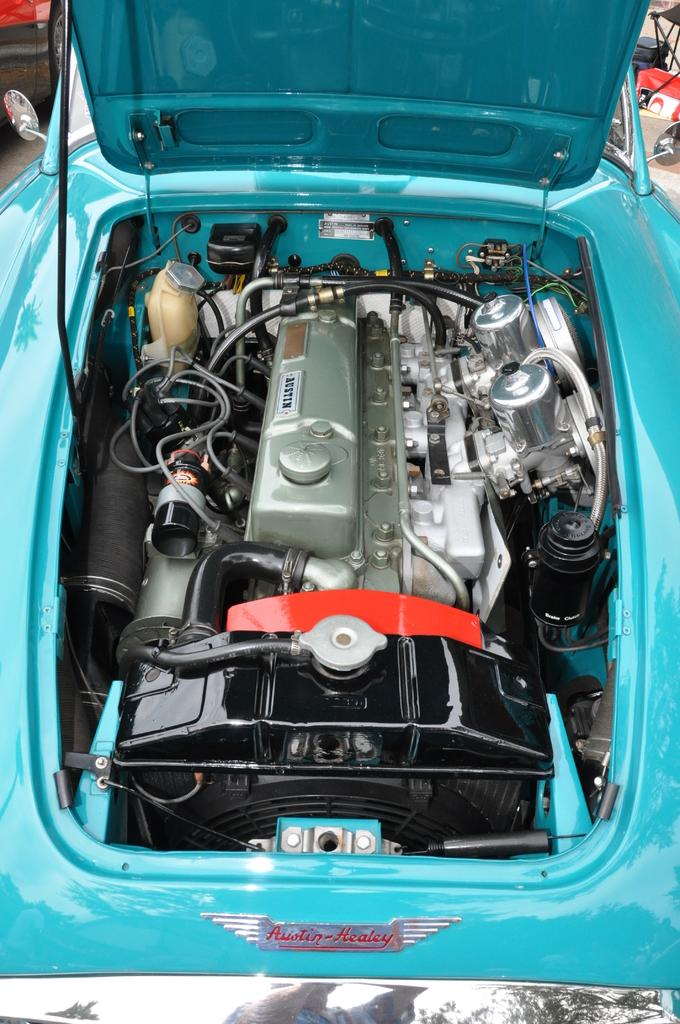What is the main subject of the image? The main subject of the image is a car engine. Can you describe the car that the engine belongs to? The car is green in color. What type of sign can be seen in the afternoon in the image? There is no sign or reference to a specific time of day in the image, so it is not possible to answer that question. 